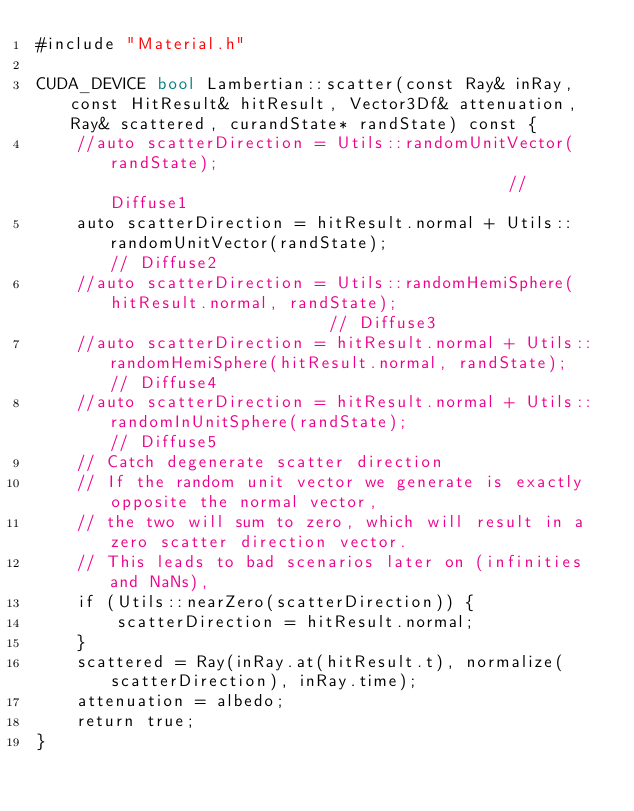Convert code to text. <code><loc_0><loc_0><loc_500><loc_500><_Cuda_>#include "Material.h"

CUDA_DEVICE bool Lambertian::scatter(const Ray& inRay, const HitResult& hitResult, Vector3Df& attenuation, Ray& scattered, curandState* randState) const {
    //auto scatterDirection = Utils::randomUnitVector(randState);                                         // Diffuse1
    auto scatterDirection = hitResult.normal + Utils::randomUnitVector(randState);                      // Diffuse2
    //auto scatterDirection = Utils::randomHemiSphere(hitResult.normal, randState);                       // Diffuse3
    //auto scatterDirection = hitResult.normal + Utils::randomHemiSphere(hitResult.normal, randState);    // Diffuse4
    //auto scatterDirection = hitResult.normal + Utils::randomInUnitSphere(randState);                    // Diffuse5
    // Catch degenerate scatter direction
    // If the random unit vector we generate is exactly opposite the normal vector, 
    // the two will sum to zero, which will result in a zero scatter direction vector. 
    // This leads to bad scenarios later on (infinities and NaNs),
    if (Utils::nearZero(scatterDirection)) {
        scatterDirection = hitResult.normal;
    }
    scattered = Ray(inRay.at(hitResult.t), normalize(scatterDirection), inRay.time);
    attenuation = albedo;
    return true;
}</code> 